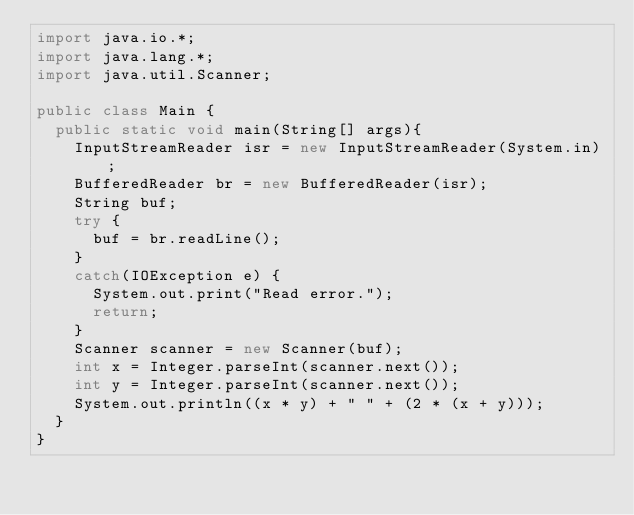<code> <loc_0><loc_0><loc_500><loc_500><_Java_>import java.io.*;
import java.lang.*;
import java.util.Scanner;

public class Main {
	public static void main(String[] args){
		InputStreamReader isr = new InputStreamReader(System.in);
		BufferedReader br = new BufferedReader(isr);
		String buf;
		try {
			buf = br.readLine();
		}
		catch(IOException e) {
			System.out.print("Read error.");
			return;
		}
		Scanner scanner = new Scanner(buf);
		int x = Integer.parseInt(scanner.next());
		int y = Integer.parseInt(scanner.next());
		System.out.println((x * y) + " " + (2 * (x + y)));
	}
}</code> 